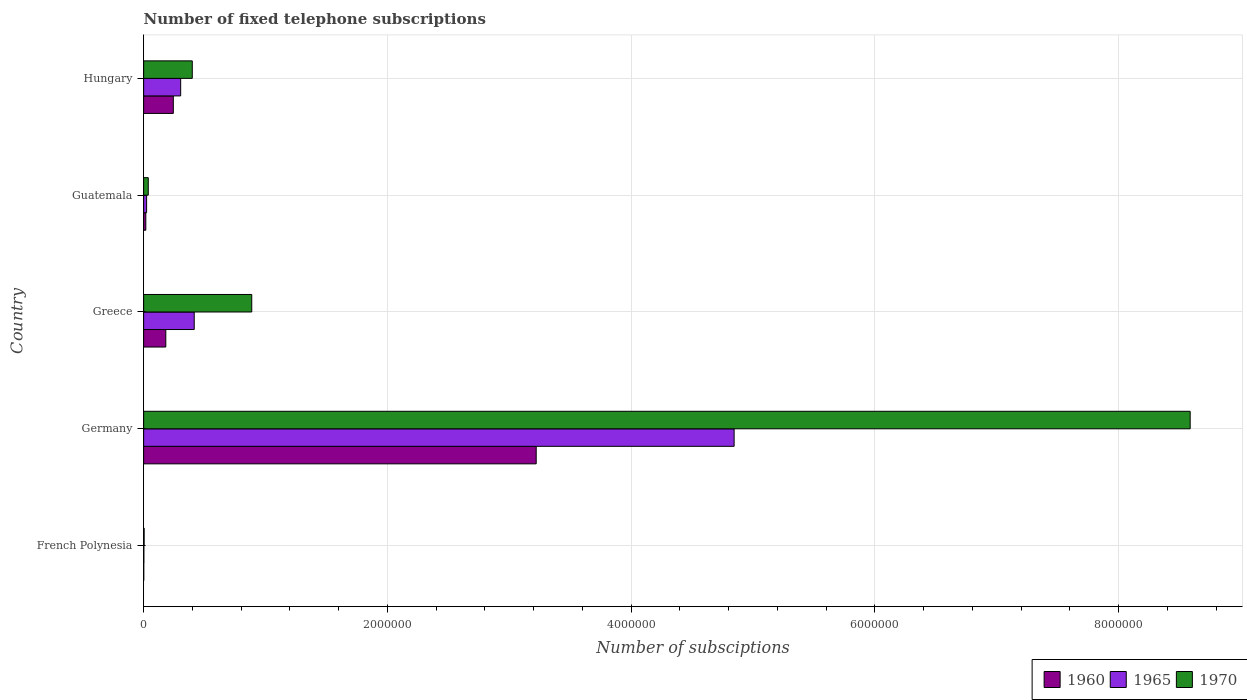How many groups of bars are there?
Offer a terse response. 5. How many bars are there on the 3rd tick from the top?
Make the answer very short. 3. How many bars are there on the 2nd tick from the bottom?
Keep it short and to the point. 3. What is the label of the 3rd group of bars from the top?
Make the answer very short. Greece. In how many cases, is the number of bars for a given country not equal to the number of legend labels?
Provide a succinct answer. 0. What is the number of fixed telephone subscriptions in 1960 in Guatemala?
Your answer should be very brief. 1.78e+04. Across all countries, what is the maximum number of fixed telephone subscriptions in 1960?
Your answer should be compact. 3.22e+06. Across all countries, what is the minimum number of fixed telephone subscriptions in 1965?
Keep it short and to the point. 1900. In which country was the number of fixed telephone subscriptions in 1965 maximum?
Provide a short and direct response. Germany. In which country was the number of fixed telephone subscriptions in 1960 minimum?
Your answer should be compact. French Polynesia. What is the total number of fixed telephone subscriptions in 1960 in the graph?
Keep it short and to the point. 3.66e+06. What is the difference between the number of fixed telephone subscriptions in 1960 in Germany and that in Guatemala?
Offer a terse response. 3.20e+06. What is the difference between the number of fixed telephone subscriptions in 1960 in Greece and the number of fixed telephone subscriptions in 1970 in French Polynesia?
Your answer should be compact. 1.78e+05. What is the average number of fixed telephone subscriptions in 1970 per country?
Offer a terse response. 1.98e+06. What is the difference between the number of fixed telephone subscriptions in 1970 and number of fixed telephone subscriptions in 1965 in French Polynesia?
Your answer should be very brief. 2100. What is the ratio of the number of fixed telephone subscriptions in 1960 in French Polynesia to that in Germany?
Ensure brevity in your answer.  0. Is the difference between the number of fixed telephone subscriptions in 1970 in Guatemala and Hungary greater than the difference between the number of fixed telephone subscriptions in 1965 in Guatemala and Hungary?
Make the answer very short. No. What is the difference between the highest and the second highest number of fixed telephone subscriptions in 1970?
Provide a short and direct response. 7.70e+06. What is the difference between the highest and the lowest number of fixed telephone subscriptions in 1960?
Offer a very short reply. 3.22e+06. In how many countries, is the number of fixed telephone subscriptions in 1970 greater than the average number of fixed telephone subscriptions in 1970 taken over all countries?
Your answer should be compact. 1. Is the sum of the number of fixed telephone subscriptions in 1965 in Germany and Greece greater than the maximum number of fixed telephone subscriptions in 1970 across all countries?
Provide a short and direct response. No. What does the 3rd bar from the bottom in Guatemala represents?
Your answer should be very brief. 1970. How many countries are there in the graph?
Your answer should be compact. 5. Are the values on the major ticks of X-axis written in scientific E-notation?
Provide a short and direct response. No. Does the graph contain any zero values?
Ensure brevity in your answer.  No. What is the title of the graph?
Provide a short and direct response. Number of fixed telephone subscriptions. What is the label or title of the X-axis?
Your response must be concise. Number of subsciptions. What is the label or title of the Y-axis?
Your response must be concise. Country. What is the Number of subsciptions of 1960 in French Polynesia?
Your response must be concise. 827. What is the Number of subsciptions of 1965 in French Polynesia?
Offer a terse response. 1900. What is the Number of subsciptions of 1970 in French Polynesia?
Ensure brevity in your answer.  4000. What is the Number of subsciptions of 1960 in Germany?
Give a very brief answer. 3.22e+06. What is the Number of subsciptions of 1965 in Germany?
Ensure brevity in your answer.  4.84e+06. What is the Number of subsciptions in 1970 in Germany?
Your answer should be compact. 8.59e+06. What is the Number of subsciptions of 1960 in Greece?
Offer a terse response. 1.82e+05. What is the Number of subsciptions in 1965 in Greece?
Your answer should be compact. 4.15e+05. What is the Number of subsciptions in 1970 in Greece?
Ensure brevity in your answer.  8.87e+05. What is the Number of subsciptions in 1960 in Guatemala?
Offer a very short reply. 1.78e+04. What is the Number of subsciptions of 1965 in Guatemala?
Give a very brief answer. 2.43e+04. What is the Number of subsciptions of 1970 in Guatemala?
Make the answer very short. 3.79e+04. What is the Number of subsciptions of 1960 in Hungary?
Your response must be concise. 2.43e+05. What is the Number of subsciptions of 1965 in Hungary?
Make the answer very short. 3.04e+05. What is the Number of subsciptions in 1970 in Hungary?
Ensure brevity in your answer.  3.99e+05. Across all countries, what is the maximum Number of subsciptions of 1960?
Keep it short and to the point. 3.22e+06. Across all countries, what is the maximum Number of subsciptions of 1965?
Give a very brief answer. 4.84e+06. Across all countries, what is the maximum Number of subsciptions in 1970?
Your response must be concise. 8.59e+06. Across all countries, what is the minimum Number of subsciptions of 1960?
Offer a terse response. 827. Across all countries, what is the minimum Number of subsciptions of 1965?
Make the answer very short. 1900. Across all countries, what is the minimum Number of subsciptions of 1970?
Keep it short and to the point. 4000. What is the total Number of subsciptions of 1960 in the graph?
Provide a short and direct response. 3.66e+06. What is the total Number of subsciptions of 1965 in the graph?
Provide a succinct answer. 5.59e+06. What is the total Number of subsciptions of 1970 in the graph?
Offer a very short reply. 9.91e+06. What is the difference between the Number of subsciptions of 1960 in French Polynesia and that in Germany?
Provide a short and direct response. -3.22e+06. What is the difference between the Number of subsciptions in 1965 in French Polynesia and that in Germany?
Your answer should be very brief. -4.84e+06. What is the difference between the Number of subsciptions in 1970 in French Polynesia and that in Germany?
Make the answer very short. -8.58e+06. What is the difference between the Number of subsciptions of 1960 in French Polynesia and that in Greece?
Your answer should be very brief. -1.81e+05. What is the difference between the Number of subsciptions of 1965 in French Polynesia and that in Greece?
Keep it short and to the point. -4.13e+05. What is the difference between the Number of subsciptions in 1970 in French Polynesia and that in Greece?
Offer a terse response. -8.83e+05. What is the difference between the Number of subsciptions of 1960 in French Polynesia and that in Guatemala?
Your answer should be very brief. -1.70e+04. What is the difference between the Number of subsciptions in 1965 in French Polynesia and that in Guatemala?
Ensure brevity in your answer.  -2.24e+04. What is the difference between the Number of subsciptions in 1970 in French Polynesia and that in Guatemala?
Your answer should be very brief. -3.39e+04. What is the difference between the Number of subsciptions of 1960 in French Polynesia and that in Hungary?
Your answer should be very brief. -2.43e+05. What is the difference between the Number of subsciptions of 1965 in French Polynesia and that in Hungary?
Offer a very short reply. -3.02e+05. What is the difference between the Number of subsciptions of 1970 in French Polynesia and that in Hungary?
Ensure brevity in your answer.  -3.95e+05. What is the difference between the Number of subsciptions in 1960 in Germany and that in Greece?
Offer a terse response. 3.04e+06. What is the difference between the Number of subsciptions of 1965 in Germany and that in Greece?
Offer a terse response. 4.43e+06. What is the difference between the Number of subsciptions in 1970 in Germany and that in Greece?
Offer a very short reply. 7.70e+06. What is the difference between the Number of subsciptions of 1960 in Germany and that in Guatemala?
Provide a succinct answer. 3.20e+06. What is the difference between the Number of subsciptions in 1965 in Germany and that in Guatemala?
Give a very brief answer. 4.82e+06. What is the difference between the Number of subsciptions of 1970 in Germany and that in Guatemala?
Offer a very short reply. 8.55e+06. What is the difference between the Number of subsciptions in 1960 in Germany and that in Hungary?
Ensure brevity in your answer.  2.98e+06. What is the difference between the Number of subsciptions in 1965 in Germany and that in Hungary?
Offer a very short reply. 4.54e+06. What is the difference between the Number of subsciptions in 1970 in Germany and that in Hungary?
Provide a succinct answer. 8.19e+06. What is the difference between the Number of subsciptions of 1960 in Greece and that in Guatemala?
Make the answer very short. 1.64e+05. What is the difference between the Number of subsciptions in 1965 in Greece and that in Guatemala?
Your answer should be compact. 3.91e+05. What is the difference between the Number of subsciptions of 1970 in Greece and that in Guatemala?
Offer a terse response. 8.49e+05. What is the difference between the Number of subsciptions in 1960 in Greece and that in Hungary?
Provide a succinct answer. -6.17e+04. What is the difference between the Number of subsciptions of 1965 in Greece and that in Hungary?
Make the answer very short. 1.11e+05. What is the difference between the Number of subsciptions in 1970 in Greece and that in Hungary?
Provide a succinct answer. 4.88e+05. What is the difference between the Number of subsciptions in 1960 in Guatemala and that in Hungary?
Your response must be concise. -2.26e+05. What is the difference between the Number of subsciptions in 1965 in Guatemala and that in Hungary?
Your response must be concise. -2.79e+05. What is the difference between the Number of subsciptions of 1970 in Guatemala and that in Hungary?
Give a very brief answer. -3.61e+05. What is the difference between the Number of subsciptions of 1960 in French Polynesia and the Number of subsciptions of 1965 in Germany?
Make the answer very short. -4.84e+06. What is the difference between the Number of subsciptions in 1960 in French Polynesia and the Number of subsciptions in 1970 in Germany?
Ensure brevity in your answer.  -8.59e+06. What is the difference between the Number of subsciptions in 1965 in French Polynesia and the Number of subsciptions in 1970 in Germany?
Offer a very short reply. -8.59e+06. What is the difference between the Number of subsciptions of 1960 in French Polynesia and the Number of subsciptions of 1965 in Greece?
Ensure brevity in your answer.  -4.14e+05. What is the difference between the Number of subsciptions in 1960 in French Polynesia and the Number of subsciptions in 1970 in Greece?
Provide a short and direct response. -8.86e+05. What is the difference between the Number of subsciptions of 1965 in French Polynesia and the Number of subsciptions of 1970 in Greece?
Offer a very short reply. -8.85e+05. What is the difference between the Number of subsciptions of 1960 in French Polynesia and the Number of subsciptions of 1965 in Guatemala?
Provide a short and direct response. -2.35e+04. What is the difference between the Number of subsciptions in 1960 in French Polynesia and the Number of subsciptions in 1970 in Guatemala?
Provide a succinct answer. -3.70e+04. What is the difference between the Number of subsciptions in 1965 in French Polynesia and the Number of subsciptions in 1970 in Guatemala?
Make the answer very short. -3.60e+04. What is the difference between the Number of subsciptions of 1960 in French Polynesia and the Number of subsciptions of 1965 in Hungary?
Keep it short and to the point. -3.03e+05. What is the difference between the Number of subsciptions in 1960 in French Polynesia and the Number of subsciptions in 1970 in Hungary?
Your answer should be very brief. -3.98e+05. What is the difference between the Number of subsciptions in 1965 in French Polynesia and the Number of subsciptions in 1970 in Hungary?
Ensure brevity in your answer.  -3.97e+05. What is the difference between the Number of subsciptions in 1960 in Germany and the Number of subsciptions in 1965 in Greece?
Offer a very short reply. 2.81e+06. What is the difference between the Number of subsciptions of 1960 in Germany and the Number of subsciptions of 1970 in Greece?
Ensure brevity in your answer.  2.33e+06. What is the difference between the Number of subsciptions in 1965 in Germany and the Number of subsciptions in 1970 in Greece?
Offer a terse response. 3.96e+06. What is the difference between the Number of subsciptions of 1960 in Germany and the Number of subsciptions of 1965 in Guatemala?
Your answer should be compact. 3.20e+06. What is the difference between the Number of subsciptions of 1960 in Germany and the Number of subsciptions of 1970 in Guatemala?
Provide a succinct answer. 3.18e+06. What is the difference between the Number of subsciptions of 1965 in Germany and the Number of subsciptions of 1970 in Guatemala?
Your answer should be compact. 4.81e+06. What is the difference between the Number of subsciptions in 1960 in Germany and the Number of subsciptions in 1965 in Hungary?
Your answer should be very brief. 2.92e+06. What is the difference between the Number of subsciptions of 1960 in Germany and the Number of subsciptions of 1970 in Hungary?
Ensure brevity in your answer.  2.82e+06. What is the difference between the Number of subsciptions of 1965 in Germany and the Number of subsciptions of 1970 in Hungary?
Offer a very short reply. 4.45e+06. What is the difference between the Number of subsciptions of 1960 in Greece and the Number of subsciptions of 1965 in Guatemala?
Your answer should be compact. 1.57e+05. What is the difference between the Number of subsciptions of 1960 in Greece and the Number of subsciptions of 1970 in Guatemala?
Offer a very short reply. 1.44e+05. What is the difference between the Number of subsciptions in 1965 in Greece and the Number of subsciptions in 1970 in Guatemala?
Give a very brief answer. 3.77e+05. What is the difference between the Number of subsciptions in 1960 in Greece and the Number of subsciptions in 1965 in Hungary?
Your answer should be very brief. -1.22e+05. What is the difference between the Number of subsciptions of 1960 in Greece and the Number of subsciptions of 1970 in Hungary?
Make the answer very short. -2.17e+05. What is the difference between the Number of subsciptions of 1965 in Greece and the Number of subsciptions of 1970 in Hungary?
Your answer should be compact. 1.59e+04. What is the difference between the Number of subsciptions of 1960 in Guatemala and the Number of subsciptions of 1965 in Hungary?
Ensure brevity in your answer.  -2.86e+05. What is the difference between the Number of subsciptions in 1960 in Guatemala and the Number of subsciptions in 1970 in Hungary?
Give a very brief answer. -3.81e+05. What is the difference between the Number of subsciptions of 1965 in Guatemala and the Number of subsciptions of 1970 in Hungary?
Your answer should be compact. -3.75e+05. What is the average Number of subsciptions in 1960 per country?
Make the answer very short. 7.33e+05. What is the average Number of subsciptions of 1965 per country?
Offer a terse response. 1.12e+06. What is the average Number of subsciptions of 1970 per country?
Keep it short and to the point. 1.98e+06. What is the difference between the Number of subsciptions in 1960 and Number of subsciptions in 1965 in French Polynesia?
Offer a terse response. -1073. What is the difference between the Number of subsciptions of 1960 and Number of subsciptions of 1970 in French Polynesia?
Ensure brevity in your answer.  -3173. What is the difference between the Number of subsciptions of 1965 and Number of subsciptions of 1970 in French Polynesia?
Offer a very short reply. -2100. What is the difference between the Number of subsciptions in 1960 and Number of subsciptions in 1965 in Germany?
Keep it short and to the point. -1.62e+06. What is the difference between the Number of subsciptions in 1960 and Number of subsciptions in 1970 in Germany?
Your response must be concise. -5.37e+06. What is the difference between the Number of subsciptions of 1965 and Number of subsciptions of 1970 in Germany?
Provide a succinct answer. -3.74e+06. What is the difference between the Number of subsciptions in 1960 and Number of subsciptions in 1965 in Greece?
Offer a terse response. -2.33e+05. What is the difference between the Number of subsciptions of 1960 and Number of subsciptions of 1970 in Greece?
Make the answer very short. -7.05e+05. What is the difference between the Number of subsciptions in 1965 and Number of subsciptions in 1970 in Greece?
Offer a very short reply. -4.72e+05. What is the difference between the Number of subsciptions of 1960 and Number of subsciptions of 1965 in Guatemala?
Offer a terse response. -6485. What is the difference between the Number of subsciptions of 1960 and Number of subsciptions of 1970 in Guatemala?
Provide a short and direct response. -2.00e+04. What is the difference between the Number of subsciptions in 1965 and Number of subsciptions in 1970 in Guatemala?
Make the answer very short. -1.36e+04. What is the difference between the Number of subsciptions in 1960 and Number of subsciptions in 1965 in Hungary?
Offer a very short reply. -6.04e+04. What is the difference between the Number of subsciptions in 1960 and Number of subsciptions in 1970 in Hungary?
Ensure brevity in your answer.  -1.56e+05. What is the difference between the Number of subsciptions of 1965 and Number of subsciptions of 1970 in Hungary?
Your answer should be very brief. -9.53e+04. What is the ratio of the Number of subsciptions in 1970 in French Polynesia to that in Germany?
Make the answer very short. 0. What is the ratio of the Number of subsciptions of 1960 in French Polynesia to that in Greece?
Offer a terse response. 0. What is the ratio of the Number of subsciptions of 1965 in French Polynesia to that in Greece?
Keep it short and to the point. 0. What is the ratio of the Number of subsciptions of 1970 in French Polynesia to that in Greece?
Provide a succinct answer. 0. What is the ratio of the Number of subsciptions of 1960 in French Polynesia to that in Guatemala?
Offer a very short reply. 0.05. What is the ratio of the Number of subsciptions of 1965 in French Polynesia to that in Guatemala?
Provide a short and direct response. 0.08. What is the ratio of the Number of subsciptions in 1970 in French Polynesia to that in Guatemala?
Give a very brief answer. 0.11. What is the ratio of the Number of subsciptions in 1960 in French Polynesia to that in Hungary?
Ensure brevity in your answer.  0. What is the ratio of the Number of subsciptions in 1965 in French Polynesia to that in Hungary?
Provide a succinct answer. 0.01. What is the ratio of the Number of subsciptions in 1960 in Germany to that in Greece?
Your answer should be compact. 17.72. What is the ratio of the Number of subsciptions of 1965 in Germany to that in Greece?
Your answer should be compact. 11.67. What is the ratio of the Number of subsciptions of 1970 in Germany to that in Greece?
Offer a terse response. 9.68. What is the ratio of the Number of subsciptions of 1960 in Germany to that in Guatemala?
Your answer should be very brief. 180.74. What is the ratio of the Number of subsciptions of 1965 in Germany to that in Guatemala?
Provide a succinct answer. 199.33. What is the ratio of the Number of subsciptions in 1970 in Germany to that in Guatemala?
Keep it short and to the point. 226.74. What is the ratio of the Number of subsciptions in 1960 in Germany to that in Hungary?
Your answer should be very brief. 13.23. What is the ratio of the Number of subsciptions in 1965 in Germany to that in Hungary?
Provide a succinct answer. 15.95. What is the ratio of the Number of subsciptions in 1970 in Germany to that in Hungary?
Make the answer very short. 21.52. What is the ratio of the Number of subsciptions of 1960 in Greece to that in Guatemala?
Your response must be concise. 10.2. What is the ratio of the Number of subsciptions in 1965 in Greece to that in Guatemala?
Make the answer very short. 17.07. What is the ratio of the Number of subsciptions in 1970 in Greece to that in Guatemala?
Your answer should be very brief. 23.42. What is the ratio of the Number of subsciptions in 1960 in Greece to that in Hungary?
Provide a succinct answer. 0.75. What is the ratio of the Number of subsciptions in 1965 in Greece to that in Hungary?
Offer a terse response. 1.37. What is the ratio of the Number of subsciptions of 1970 in Greece to that in Hungary?
Provide a succinct answer. 2.22. What is the ratio of the Number of subsciptions in 1960 in Guatemala to that in Hungary?
Provide a short and direct response. 0.07. What is the ratio of the Number of subsciptions of 1965 in Guatemala to that in Hungary?
Offer a very short reply. 0.08. What is the ratio of the Number of subsciptions of 1970 in Guatemala to that in Hungary?
Your answer should be compact. 0.09. What is the difference between the highest and the second highest Number of subsciptions in 1960?
Keep it short and to the point. 2.98e+06. What is the difference between the highest and the second highest Number of subsciptions in 1965?
Give a very brief answer. 4.43e+06. What is the difference between the highest and the second highest Number of subsciptions in 1970?
Your response must be concise. 7.70e+06. What is the difference between the highest and the lowest Number of subsciptions in 1960?
Offer a terse response. 3.22e+06. What is the difference between the highest and the lowest Number of subsciptions of 1965?
Offer a very short reply. 4.84e+06. What is the difference between the highest and the lowest Number of subsciptions of 1970?
Provide a succinct answer. 8.58e+06. 